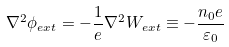<formula> <loc_0><loc_0><loc_500><loc_500>\nabla ^ { 2 } \phi _ { e x t } = - \frac { 1 } { e } \nabla ^ { 2 } W _ { e x t } \equiv - \frac { n _ { 0 } e } { \varepsilon _ { 0 } }</formula> 